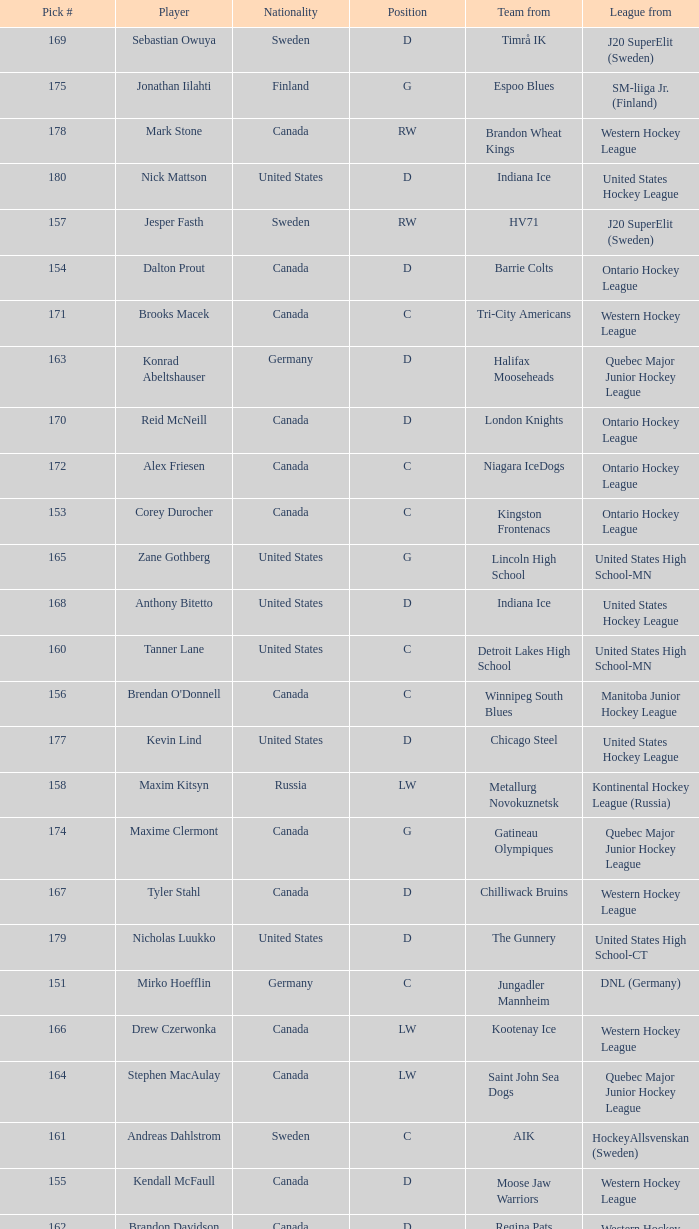What is the position of the team player from Aik? C. 